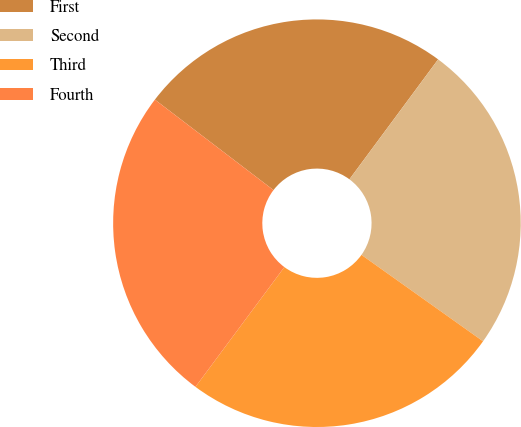<chart> <loc_0><loc_0><loc_500><loc_500><pie_chart><fcel>First<fcel>Second<fcel>Third<fcel>Fourth<nl><fcel>24.77%<fcel>24.7%<fcel>25.33%<fcel>25.21%<nl></chart> 